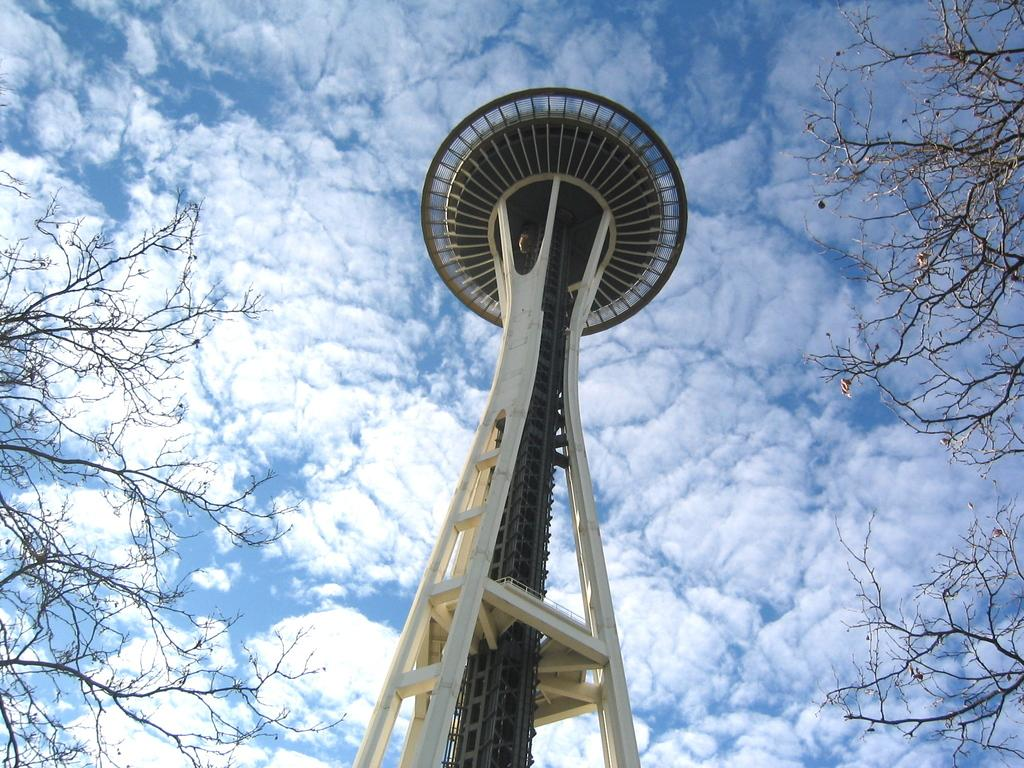What is the main structure in the image? There is a tower in the image. What can be seen on the left side of the image? There are trees on the left side of the image. What can be seen on the right side of the image? There are trees on the right side of the image. What is visible at the top of the image? The sky is visible at the top of the image. What is the weather like in the image? The sky appears to be sunny, suggesting a clear and bright day. What type of guitar is being played by the animal in the image? There is no guitar or animal present in the image. 